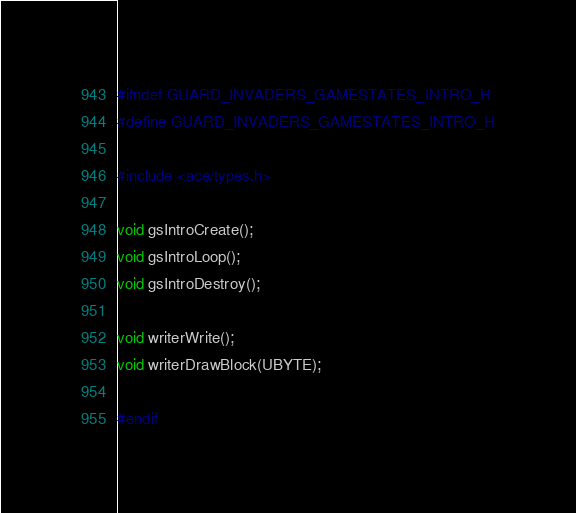Convert code to text. <code><loc_0><loc_0><loc_500><loc_500><_C_>#ifndef GUARD_INVADERS_GAMESTATES_INTRO_H
#define GUARD_INVADERS_GAMESTATES_INTRO_H

#include <ace/types.h>

void gsIntroCreate();
void gsIntroLoop();
void gsIntroDestroy();

void writerWrite();
void writerDrawBlock(UBYTE);

#endif</code> 